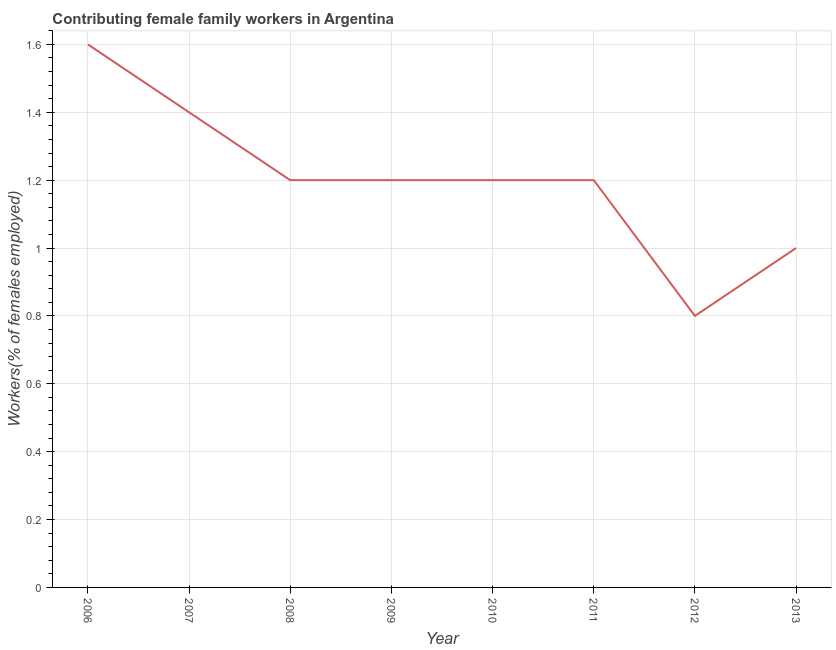What is the contributing female family workers in 2013?
Ensure brevity in your answer.  1. Across all years, what is the maximum contributing female family workers?
Make the answer very short. 1.6. Across all years, what is the minimum contributing female family workers?
Your answer should be very brief. 0.8. In which year was the contributing female family workers maximum?
Your answer should be compact. 2006. What is the sum of the contributing female family workers?
Your response must be concise. 9.6. What is the difference between the contributing female family workers in 2006 and 2010?
Provide a succinct answer. 0.4. What is the average contributing female family workers per year?
Provide a succinct answer. 1.2. What is the median contributing female family workers?
Make the answer very short. 1.2. In how many years, is the contributing female family workers greater than 1.04 %?
Offer a very short reply. 6. Do a majority of the years between 2007 and 2008 (inclusive) have contributing female family workers greater than 0.56 %?
Provide a short and direct response. Yes. What is the ratio of the contributing female family workers in 2008 to that in 2011?
Ensure brevity in your answer.  1. What is the difference between the highest and the second highest contributing female family workers?
Ensure brevity in your answer.  0.2. Is the sum of the contributing female family workers in 2009 and 2013 greater than the maximum contributing female family workers across all years?
Make the answer very short. Yes. What is the difference between the highest and the lowest contributing female family workers?
Ensure brevity in your answer.  0.8. In how many years, is the contributing female family workers greater than the average contributing female family workers taken over all years?
Keep it short and to the point. 6. Does the contributing female family workers monotonically increase over the years?
Your response must be concise. No. How many years are there in the graph?
Provide a short and direct response. 8. What is the difference between two consecutive major ticks on the Y-axis?
Keep it short and to the point. 0.2. Are the values on the major ticks of Y-axis written in scientific E-notation?
Offer a terse response. No. Does the graph contain any zero values?
Offer a very short reply. No. What is the title of the graph?
Ensure brevity in your answer.  Contributing female family workers in Argentina. What is the label or title of the X-axis?
Keep it short and to the point. Year. What is the label or title of the Y-axis?
Your answer should be very brief. Workers(% of females employed). What is the Workers(% of females employed) of 2006?
Provide a short and direct response. 1.6. What is the Workers(% of females employed) of 2007?
Offer a terse response. 1.4. What is the Workers(% of females employed) of 2008?
Provide a short and direct response. 1.2. What is the Workers(% of females employed) of 2009?
Your response must be concise. 1.2. What is the Workers(% of females employed) in 2010?
Your answer should be compact. 1.2. What is the Workers(% of females employed) of 2011?
Ensure brevity in your answer.  1.2. What is the Workers(% of females employed) of 2012?
Your answer should be very brief. 0.8. What is the Workers(% of females employed) of 2013?
Your answer should be very brief. 1. What is the difference between the Workers(% of females employed) in 2006 and 2009?
Keep it short and to the point. 0.4. What is the difference between the Workers(% of females employed) in 2006 and 2011?
Provide a succinct answer. 0.4. What is the difference between the Workers(% of females employed) in 2006 and 2012?
Provide a short and direct response. 0.8. What is the difference between the Workers(% of females employed) in 2006 and 2013?
Ensure brevity in your answer.  0.6. What is the difference between the Workers(% of females employed) in 2007 and 2011?
Provide a short and direct response. 0.2. What is the difference between the Workers(% of females employed) in 2007 and 2012?
Provide a succinct answer. 0.6. What is the difference between the Workers(% of females employed) in 2008 and 2009?
Offer a very short reply. 0. What is the difference between the Workers(% of females employed) in 2008 and 2010?
Keep it short and to the point. 0. What is the difference between the Workers(% of females employed) in 2008 and 2012?
Provide a succinct answer. 0.4. What is the difference between the Workers(% of females employed) in 2009 and 2010?
Your answer should be very brief. 0. What is the difference between the Workers(% of females employed) in 2009 and 2011?
Give a very brief answer. 0. What is the difference between the Workers(% of females employed) in 2009 and 2012?
Your answer should be compact. 0.4. What is the difference between the Workers(% of females employed) in 2009 and 2013?
Your answer should be very brief. 0.2. What is the difference between the Workers(% of females employed) in 2010 and 2012?
Your answer should be compact. 0.4. What is the difference between the Workers(% of females employed) in 2010 and 2013?
Your answer should be compact. 0.2. What is the difference between the Workers(% of females employed) in 2011 and 2012?
Ensure brevity in your answer.  0.4. What is the difference between the Workers(% of females employed) in 2012 and 2013?
Provide a succinct answer. -0.2. What is the ratio of the Workers(% of females employed) in 2006 to that in 2007?
Give a very brief answer. 1.14. What is the ratio of the Workers(% of females employed) in 2006 to that in 2008?
Keep it short and to the point. 1.33. What is the ratio of the Workers(% of females employed) in 2006 to that in 2009?
Offer a terse response. 1.33. What is the ratio of the Workers(% of females employed) in 2006 to that in 2010?
Your response must be concise. 1.33. What is the ratio of the Workers(% of females employed) in 2006 to that in 2011?
Your answer should be compact. 1.33. What is the ratio of the Workers(% of females employed) in 2006 to that in 2013?
Give a very brief answer. 1.6. What is the ratio of the Workers(% of females employed) in 2007 to that in 2008?
Your response must be concise. 1.17. What is the ratio of the Workers(% of females employed) in 2007 to that in 2009?
Your response must be concise. 1.17. What is the ratio of the Workers(% of females employed) in 2007 to that in 2010?
Ensure brevity in your answer.  1.17. What is the ratio of the Workers(% of females employed) in 2007 to that in 2011?
Your answer should be compact. 1.17. What is the ratio of the Workers(% of females employed) in 2007 to that in 2013?
Provide a short and direct response. 1.4. What is the ratio of the Workers(% of females employed) in 2008 to that in 2011?
Offer a very short reply. 1. What is the ratio of the Workers(% of females employed) in 2008 to that in 2013?
Make the answer very short. 1.2. What is the ratio of the Workers(% of females employed) in 2009 to that in 2010?
Provide a succinct answer. 1. What is the ratio of the Workers(% of females employed) in 2009 to that in 2012?
Keep it short and to the point. 1.5. What is the ratio of the Workers(% of females employed) in 2010 to that in 2011?
Keep it short and to the point. 1. What is the ratio of the Workers(% of females employed) in 2011 to that in 2012?
Make the answer very short. 1.5. What is the ratio of the Workers(% of females employed) in 2011 to that in 2013?
Provide a short and direct response. 1.2. 